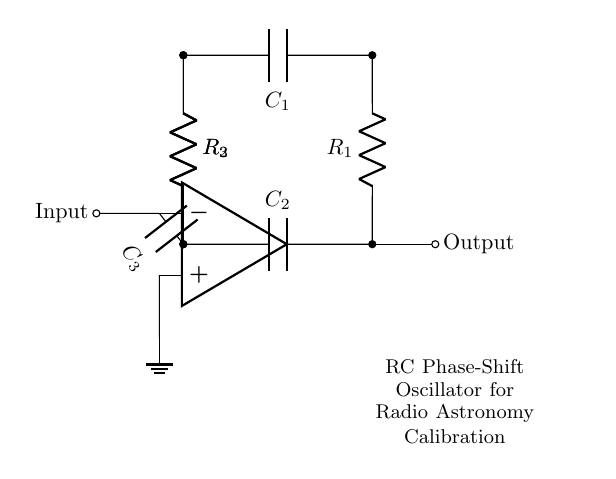What is the role of the op-amp in this circuit? The op-amp functions as a voltage amplifier, providing the necessary gain to sustain oscillation in the RC phase-shift oscillator. It takes the input signal at the non-inverting terminal and provides an amplified output which is used in the feedback loop.
Answer: Voltage amplifier How many capacitors are present in the circuit? There are three capacitors labeled C1, C2, and C3, which are crucial in providing the phase shift needed for oscillation.
Answer: Three What is the function of the resistors in this oscillator? The resistors (R1, R2, and R3) work in tandem with the capacitors to determine the frequency of oscillation through their values, which affect the timing characteristics of the circuit.
Answer: Timing What is the value of the phase shift achieved by the capacitor-resistor network? Each RC stage contributes a phase shift of 60 degrees, and since there are three stages, the total phase shift is 180 degrees, which is essential for oscillation. The op-amp inverts the signal, leading to a total phase shift of 360 degrees.
Answer: 360 degrees How are the output and input connected in this circuit? The output from the op-amp is connected directly to the input of the first resistor, completing the feedback loop essential for maintaining oscillations. This connection forms a critical part of the oscillator's operation.
Answer: Feedback loop What type of oscillation does this circuit produce? This circuit generates sinusoidal oscillations due to the natural behavior of the RC components in conjunction with the op-amp. The natural oscillation is a result of continuous charge and discharge of the capacitors.
Answer: Sinusoidal What does the ground symbolize in this circuit? The ground represents a common reference point for voltages in the circuit, ensuring stability and providing a return path for current. It completes the circuit, allowing for proper operation of all components.
Answer: Common reference 